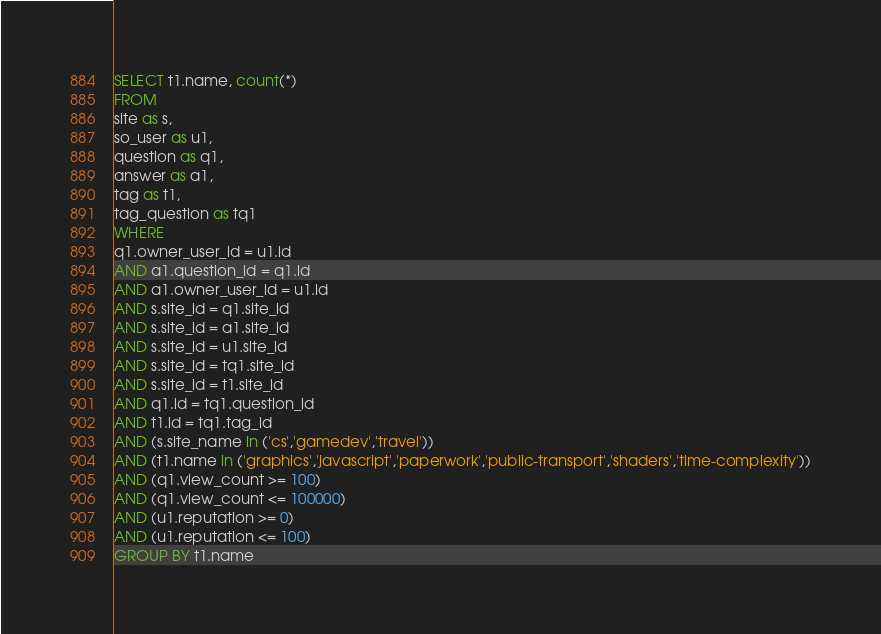Convert code to text. <code><loc_0><loc_0><loc_500><loc_500><_SQL_>SELECT t1.name, count(*)
FROM
site as s,
so_user as u1,
question as q1,
answer as a1,
tag as t1,
tag_question as tq1
WHERE
q1.owner_user_id = u1.id
AND a1.question_id = q1.id
AND a1.owner_user_id = u1.id
AND s.site_id = q1.site_id
AND s.site_id = a1.site_id
AND s.site_id = u1.site_id
AND s.site_id = tq1.site_id
AND s.site_id = t1.site_id
AND q1.id = tq1.question_id
AND t1.id = tq1.tag_id
AND (s.site_name in ('cs','gamedev','travel'))
AND (t1.name in ('graphics','javascript','paperwork','public-transport','shaders','time-complexity'))
AND (q1.view_count >= 100)
AND (q1.view_count <= 100000)
AND (u1.reputation >= 0)
AND (u1.reputation <= 100)
GROUP BY t1.name</code> 